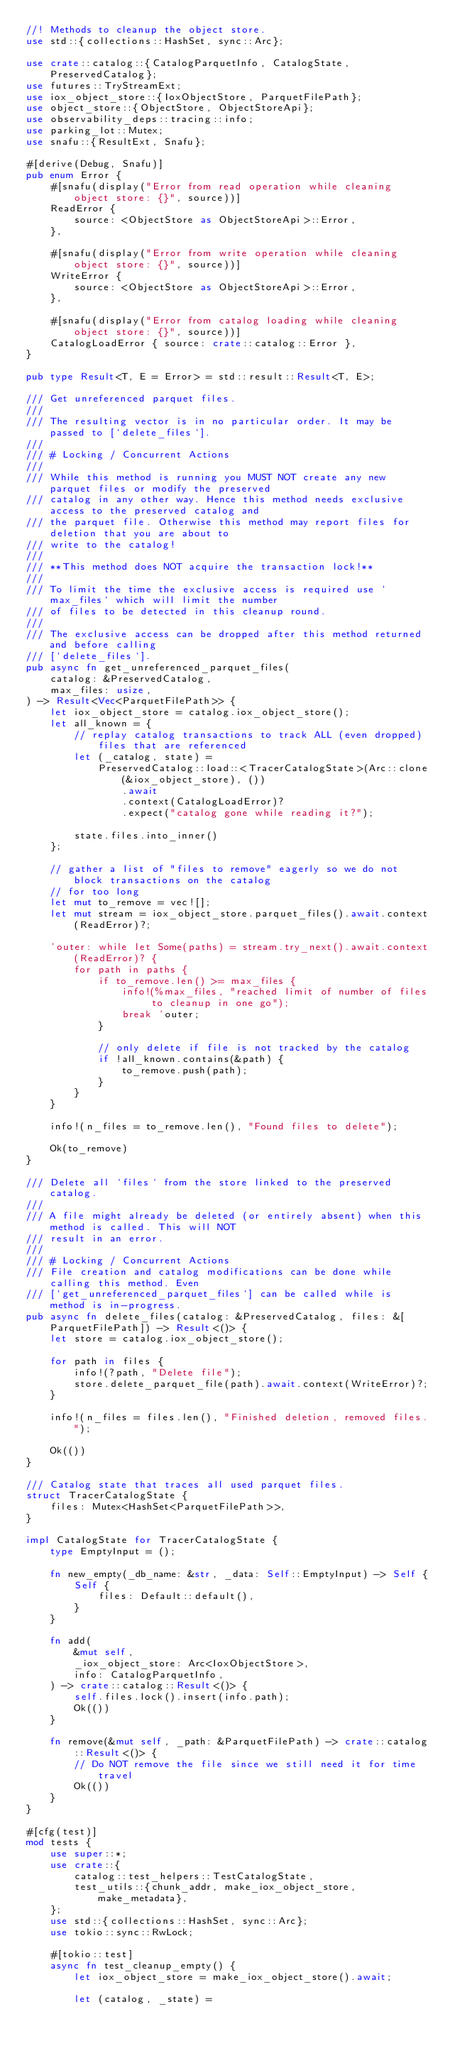Convert code to text. <code><loc_0><loc_0><loc_500><loc_500><_Rust_>//! Methods to cleanup the object store.
use std::{collections::HashSet, sync::Arc};

use crate::catalog::{CatalogParquetInfo, CatalogState, PreservedCatalog};
use futures::TryStreamExt;
use iox_object_store::{IoxObjectStore, ParquetFilePath};
use object_store::{ObjectStore, ObjectStoreApi};
use observability_deps::tracing::info;
use parking_lot::Mutex;
use snafu::{ResultExt, Snafu};

#[derive(Debug, Snafu)]
pub enum Error {
    #[snafu(display("Error from read operation while cleaning object store: {}", source))]
    ReadError {
        source: <ObjectStore as ObjectStoreApi>::Error,
    },

    #[snafu(display("Error from write operation while cleaning object store: {}", source))]
    WriteError {
        source: <ObjectStore as ObjectStoreApi>::Error,
    },

    #[snafu(display("Error from catalog loading while cleaning object store: {}", source))]
    CatalogLoadError { source: crate::catalog::Error },
}

pub type Result<T, E = Error> = std::result::Result<T, E>;

/// Get unreferenced parquet files.
///
/// The resulting vector is in no particular order. It may be passed to [`delete_files`].
///
/// # Locking / Concurrent Actions
///
/// While this method is running you MUST NOT create any new parquet files or modify the preserved
/// catalog in any other way. Hence this method needs exclusive access to the preserved catalog and
/// the parquet file. Otherwise this method may report files for deletion that you are about to
/// write to the catalog!
///
/// **This method does NOT acquire the transaction lock!**
///
/// To limit the time the exclusive access is required use `max_files` which will limit the number
/// of files to be detected in this cleanup round.
///
/// The exclusive access can be dropped after this method returned and before calling
/// [`delete_files`].
pub async fn get_unreferenced_parquet_files(
    catalog: &PreservedCatalog,
    max_files: usize,
) -> Result<Vec<ParquetFilePath>> {
    let iox_object_store = catalog.iox_object_store();
    let all_known = {
        // replay catalog transactions to track ALL (even dropped) files that are referenced
        let (_catalog, state) =
            PreservedCatalog::load::<TracerCatalogState>(Arc::clone(&iox_object_store), ())
                .await
                .context(CatalogLoadError)?
                .expect("catalog gone while reading it?");

        state.files.into_inner()
    };

    // gather a list of "files to remove" eagerly so we do not block transactions on the catalog
    // for too long
    let mut to_remove = vec![];
    let mut stream = iox_object_store.parquet_files().await.context(ReadError)?;

    'outer: while let Some(paths) = stream.try_next().await.context(ReadError)? {
        for path in paths {
            if to_remove.len() >= max_files {
                info!(%max_files, "reached limit of number of files to cleanup in one go");
                break 'outer;
            }

            // only delete if file is not tracked by the catalog
            if !all_known.contains(&path) {
                to_remove.push(path);
            }
        }
    }

    info!(n_files = to_remove.len(), "Found files to delete");

    Ok(to_remove)
}

/// Delete all `files` from the store linked to the preserved catalog.
///
/// A file might already be deleted (or entirely absent) when this method is called. This will NOT
/// result in an error.
///
/// # Locking / Concurrent Actions
/// File creation and catalog modifications can be done while calling this method. Even
/// [`get_unreferenced_parquet_files`] can be called while is method is in-progress.
pub async fn delete_files(catalog: &PreservedCatalog, files: &[ParquetFilePath]) -> Result<()> {
    let store = catalog.iox_object_store();

    for path in files {
        info!(?path, "Delete file");
        store.delete_parquet_file(path).await.context(WriteError)?;
    }

    info!(n_files = files.len(), "Finished deletion, removed files.");

    Ok(())
}

/// Catalog state that traces all used parquet files.
struct TracerCatalogState {
    files: Mutex<HashSet<ParquetFilePath>>,
}

impl CatalogState for TracerCatalogState {
    type EmptyInput = ();

    fn new_empty(_db_name: &str, _data: Self::EmptyInput) -> Self {
        Self {
            files: Default::default(),
        }
    }

    fn add(
        &mut self,
        _iox_object_store: Arc<IoxObjectStore>,
        info: CatalogParquetInfo,
    ) -> crate::catalog::Result<()> {
        self.files.lock().insert(info.path);
        Ok(())
    }

    fn remove(&mut self, _path: &ParquetFilePath) -> crate::catalog::Result<()> {
        // Do NOT remove the file since we still need it for time travel
        Ok(())
    }
}

#[cfg(test)]
mod tests {
    use super::*;
    use crate::{
        catalog::test_helpers::TestCatalogState,
        test_utils::{chunk_addr, make_iox_object_store, make_metadata},
    };
    use std::{collections::HashSet, sync::Arc};
    use tokio::sync::RwLock;

    #[tokio::test]
    async fn test_cleanup_empty() {
        let iox_object_store = make_iox_object_store().await;

        let (catalog, _state) =</code> 